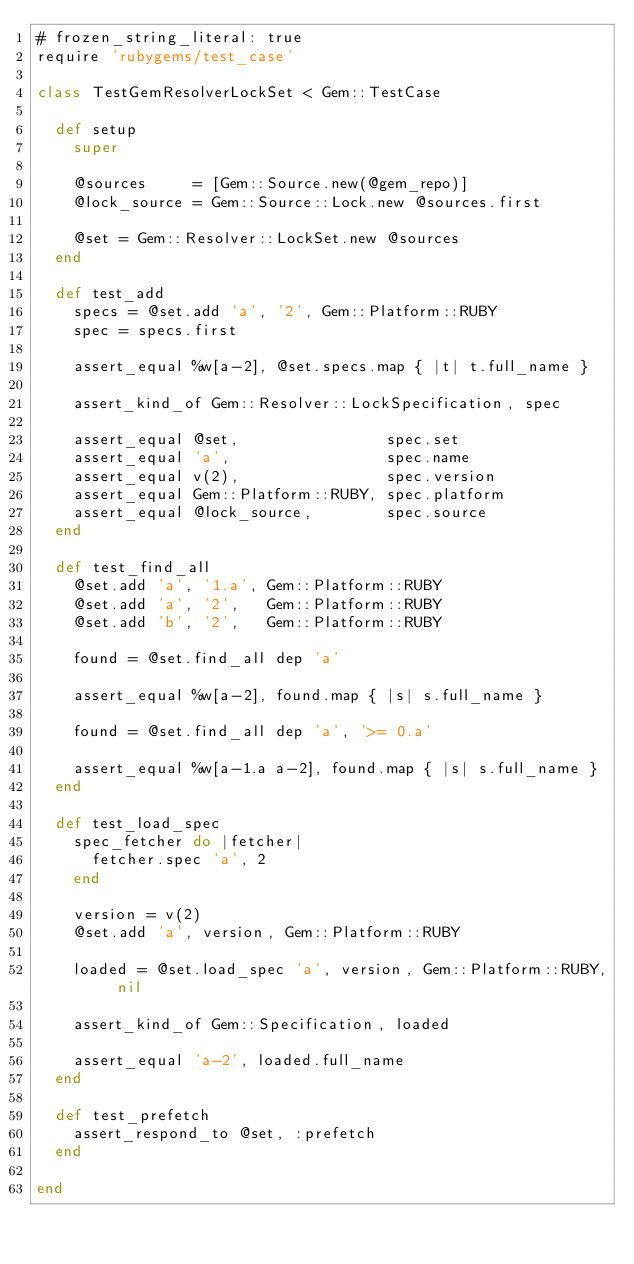<code> <loc_0><loc_0><loc_500><loc_500><_Ruby_># frozen_string_literal: true
require 'rubygems/test_case'

class TestGemResolverLockSet < Gem::TestCase

  def setup
    super

    @sources     = [Gem::Source.new(@gem_repo)]
    @lock_source = Gem::Source::Lock.new @sources.first

    @set = Gem::Resolver::LockSet.new @sources
  end

  def test_add
    specs = @set.add 'a', '2', Gem::Platform::RUBY
    spec = specs.first

    assert_equal %w[a-2], @set.specs.map { |t| t.full_name }

    assert_kind_of Gem::Resolver::LockSpecification, spec

    assert_equal @set,                spec.set
    assert_equal 'a',                 spec.name
    assert_equal v(2),                spec.version
    assert_equal Gem::Platform::RUBY, spec.platform
    assert_equal @lock_source,        spec.source
  end

  def test_find_all
    @set.add 'a', '1.a', Gem::Platform::RUBY
    @set.add 'a', '2',   Gem::Platform::RUBY
    @set.add 'b', '2',   Gem::Platform::RUBY

    found = @set.find_all dep 'a'

    assert_equal %w[a-2], found.map { |s| s.full_name }

    found = @set.find_all dep 'a', '>= 0.a'

    assert_equal %w[a-1.a a-2], found.map { |s| s.full_name }
  end

  def test_load_spec
    spec_fetcher do |fetcher|
      fetcher.spec 'a', 2
    end

    version = v(2)
    @set.add 'a', version, Gem::Platform::RUBY

    loaded = @set.load_spec 'a', version, Gem::Platform::RUBY, nil

    assert_kind_of Gem::Specification, loaded

    assert_equal 'a-2', loaded.full_name
  end

  def test_prefetch
    assert_respond_to @set, :prefetch
  end

end
</code> 